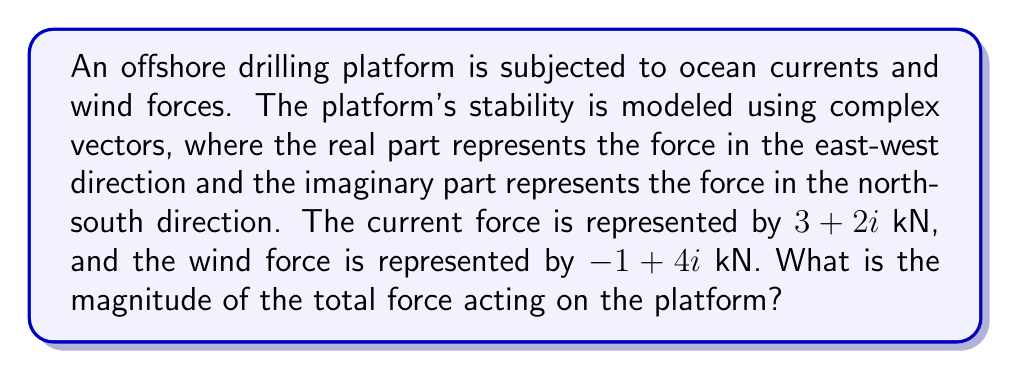Can you answer this question? To solve this problem, we'll follow these steps:

1) First, we need to add the two complex force vectors:
   Total force = Current force + Wind force
   $$(3+2i) + (-1+4i) = (3-1) + (2+4)i = 2 + 6i$$

2) Now we have the total force vector: $2 + 6i$ kN

3) To find the magnitude of this force, we use the formula:
   $$|z| = \sqrt{a^2 + b^2}$$
   where $z = a + bi$ is a complex number

4) In our case, $a = 2$ and $b = 6$:
   $$|2 + 6i| = \sqrt{2^2 + 6^2}$$

5) Let's calculate:
   $$\sqrt{2^2 + 6^2} = \sqrt{4 + 36} = \sqrt{40} = 2\sqrt{10}$$

6) Therefore, the magnitude of the total force is $2\sqrt{10}$ kN.
Answer: $2\sqrt{10}$ kN 